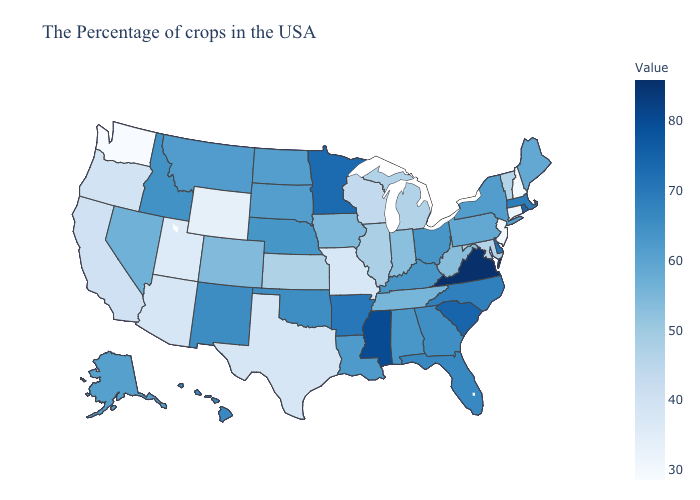Among the states that border Nebraska , which have the highest value?
Write a very short answer. South Dakota. Does Wisconsin have the lowest value in the MidWest?
Concise answer only. No. Does New Hampshire have the lowest value in the Northeast?
Short answer required. Yes. Does Idaho have a lower value than West Virginia?
Answer briefly. No. Does Oklahoma have the lowest value in the USA?
Be succinct. No. Among the states that border South Carolina , does North Carolina have the lowest value?
Answer briefly. No. 